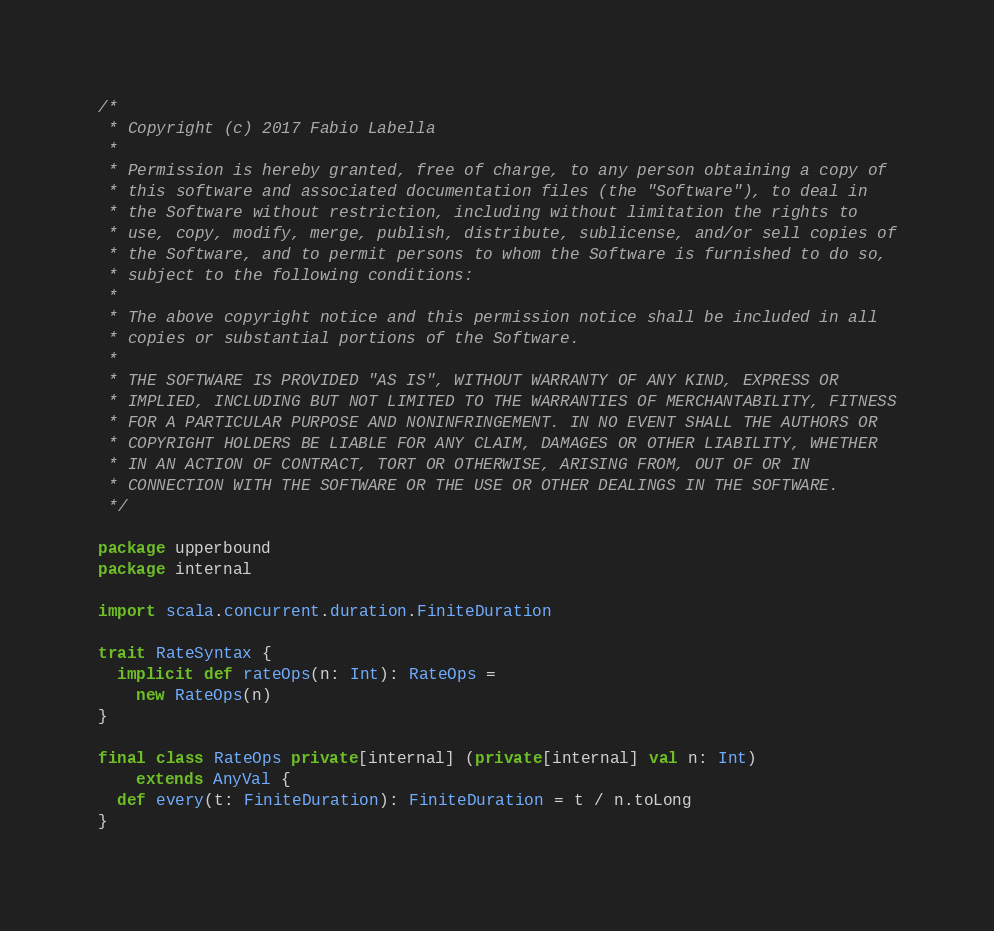Convert code to text. <code><loc_0><loc_0><loc_500><loc_500><_Scala_>/*
 * Copyright (c) 2017 Fabio Labella
 *
 * Permission is hereby granted, free of charge, to any person obtaining a copy of
 * this software and associated documentation files (the "Software"), to deal in
 * the Software without restriction, including without limitation the rights to
 * use, copy, modify, merge, publish, distribute, sublicense, and/or sell copies of
 * the Software, and to permit persons to whom the Software is furnished to do so,
 * subject to the following conditions:
 *
 * The above copyright notice and this permission notice shall be included in all
 * copies or substantial portions of the Software.
 *
 * THE SOFTWARE IS PROVIDED "AS IS", WITHOUT WARRANTY OF ANY KIND, EXPRESS OR
 * IMPLIED, INCLUDING BUT NOT LIMITED TO THE WARRANTIES OF MERCHANTABILITY, FITNESS
 * FOR A PARTICULAR PURPOSE AND NONINFRINGEMENT. IN NO EVENT SHALL THE AUTHORS OR
 * COPYRIGHT HOLDERS BE LIABLE FOR ANY CLAIM, DAMAGES OR OTHER LIABILITY, WHETHER
 * IN AN ACTION OF CONTRACT, TORT OR OTHERWISE, ARISING FROM, OUT OF OR IN
 * CONNECTION WITH THE SOFTWARE OR THE USE OR OTHER DEALINGS IN THE SOFTWARE.
 */

package upperbound
package internal

import scala.concurrent.duration.FiniteDuration

trait RateSyntax {
  implicit def rateOps(n: Int): RateOps =
    new RateOps(n)
}

final class RateOps private[internal] (private[internal] val n: Int)
    extends AnyVal {
  def every(t: FiniteDuration): FiniteDuration = t / n.toLong
}
</code> 